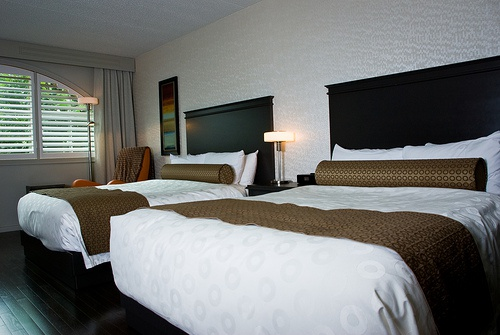Describe the objects in this image and their specific colors. I can see bed in gray, lightgray, black, and darkgray tones, bed in gray, darkgray, black, maroon, and lightgray tones, and chair in gray, maroon, and black tones in this image. 